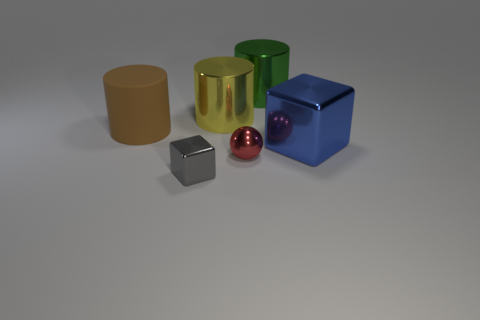Add 4 purple metallic balls. How many objects exist? 10 Subtract all blocks. How many objects are left? 4 Subtract 0 blue spheres. How many objects are left? 6 Subtract all small gray shiny objects. Subtract all big gray rubber things. How many objects are left? 5 Add 3 cylinders. How many cylinders are left? 6 Add 6 large brown matte objects. How many large brown matte objects exist? 7 